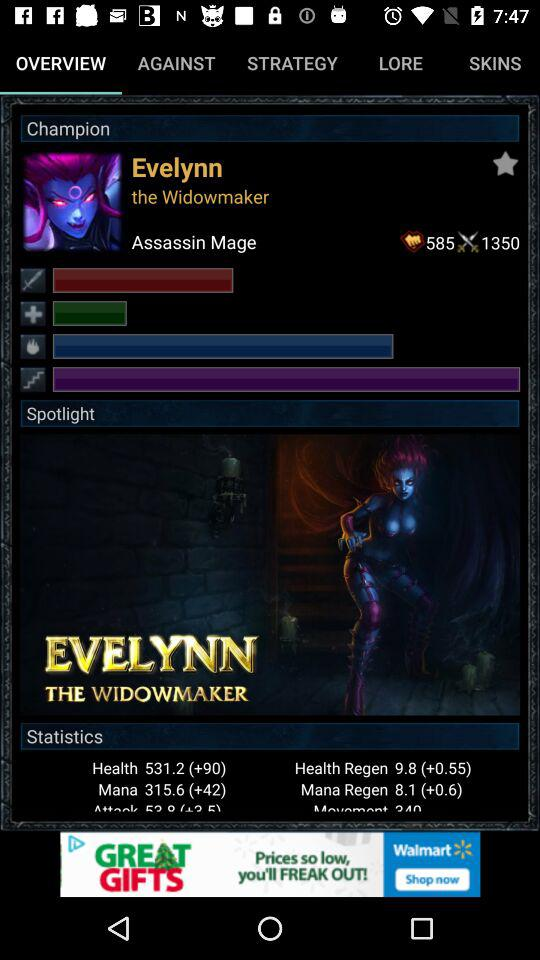What are the statistics for the "Assassin Mage"? The statistics for the "Assassin Mage" is 585*1350. 